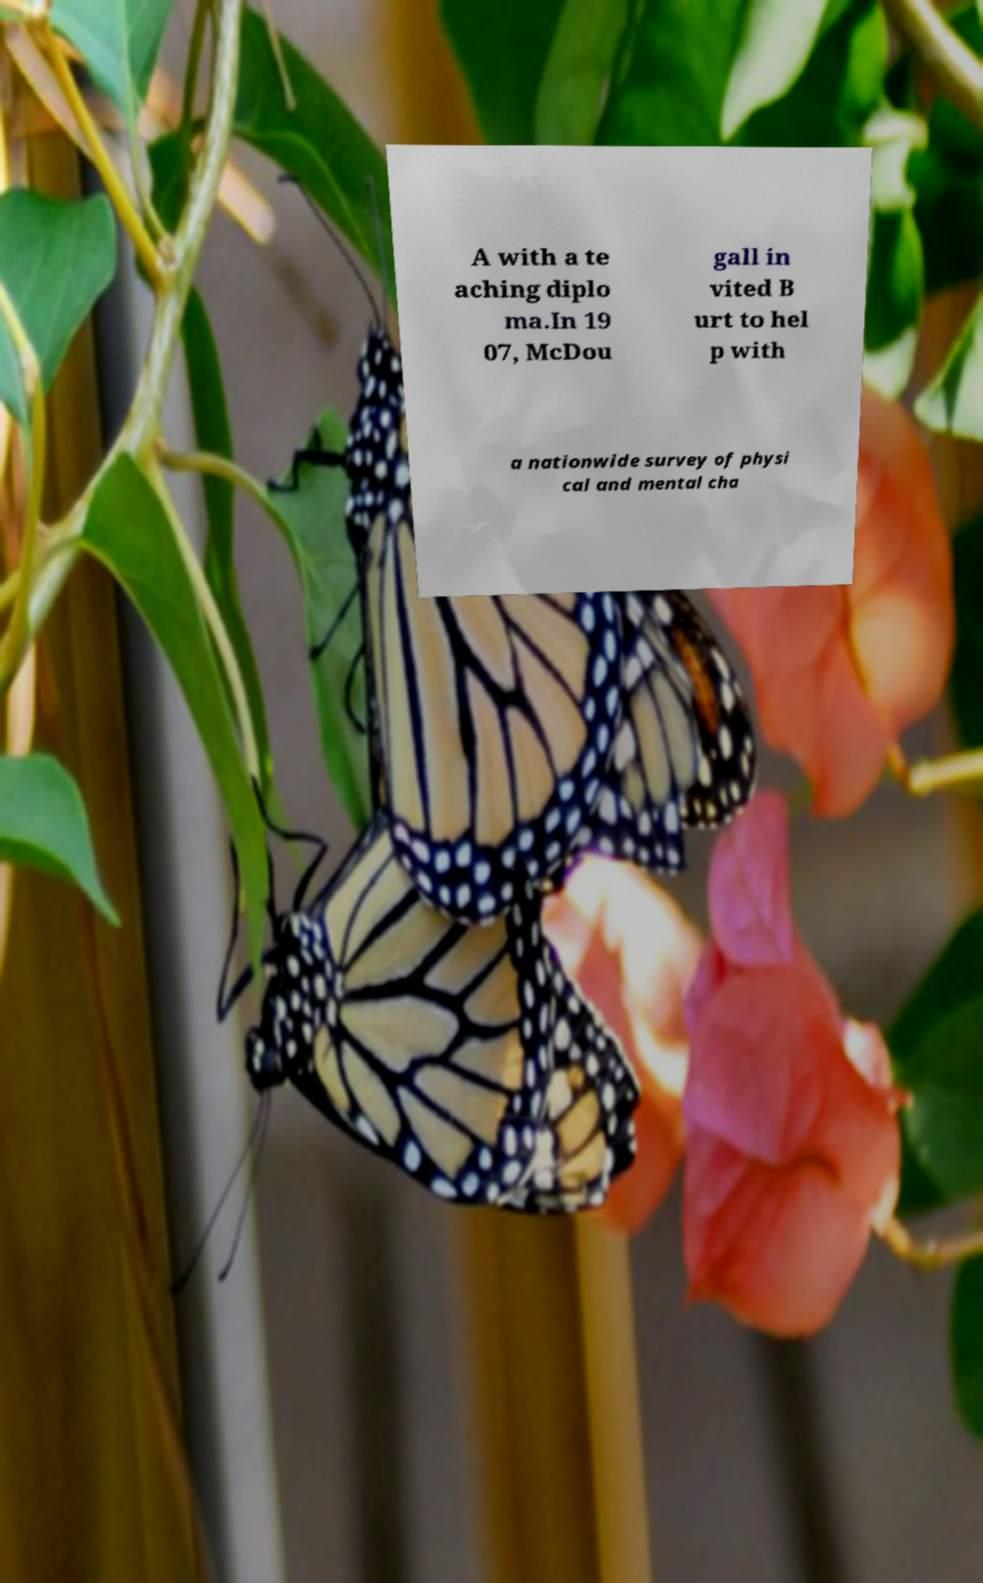Please read and relay the text visible in this image. What does it say? A with a te aching diplo ma.In 19 07, McDou gall in vited B urt to hel p with a nationwide survey of physi cal and mental cha 